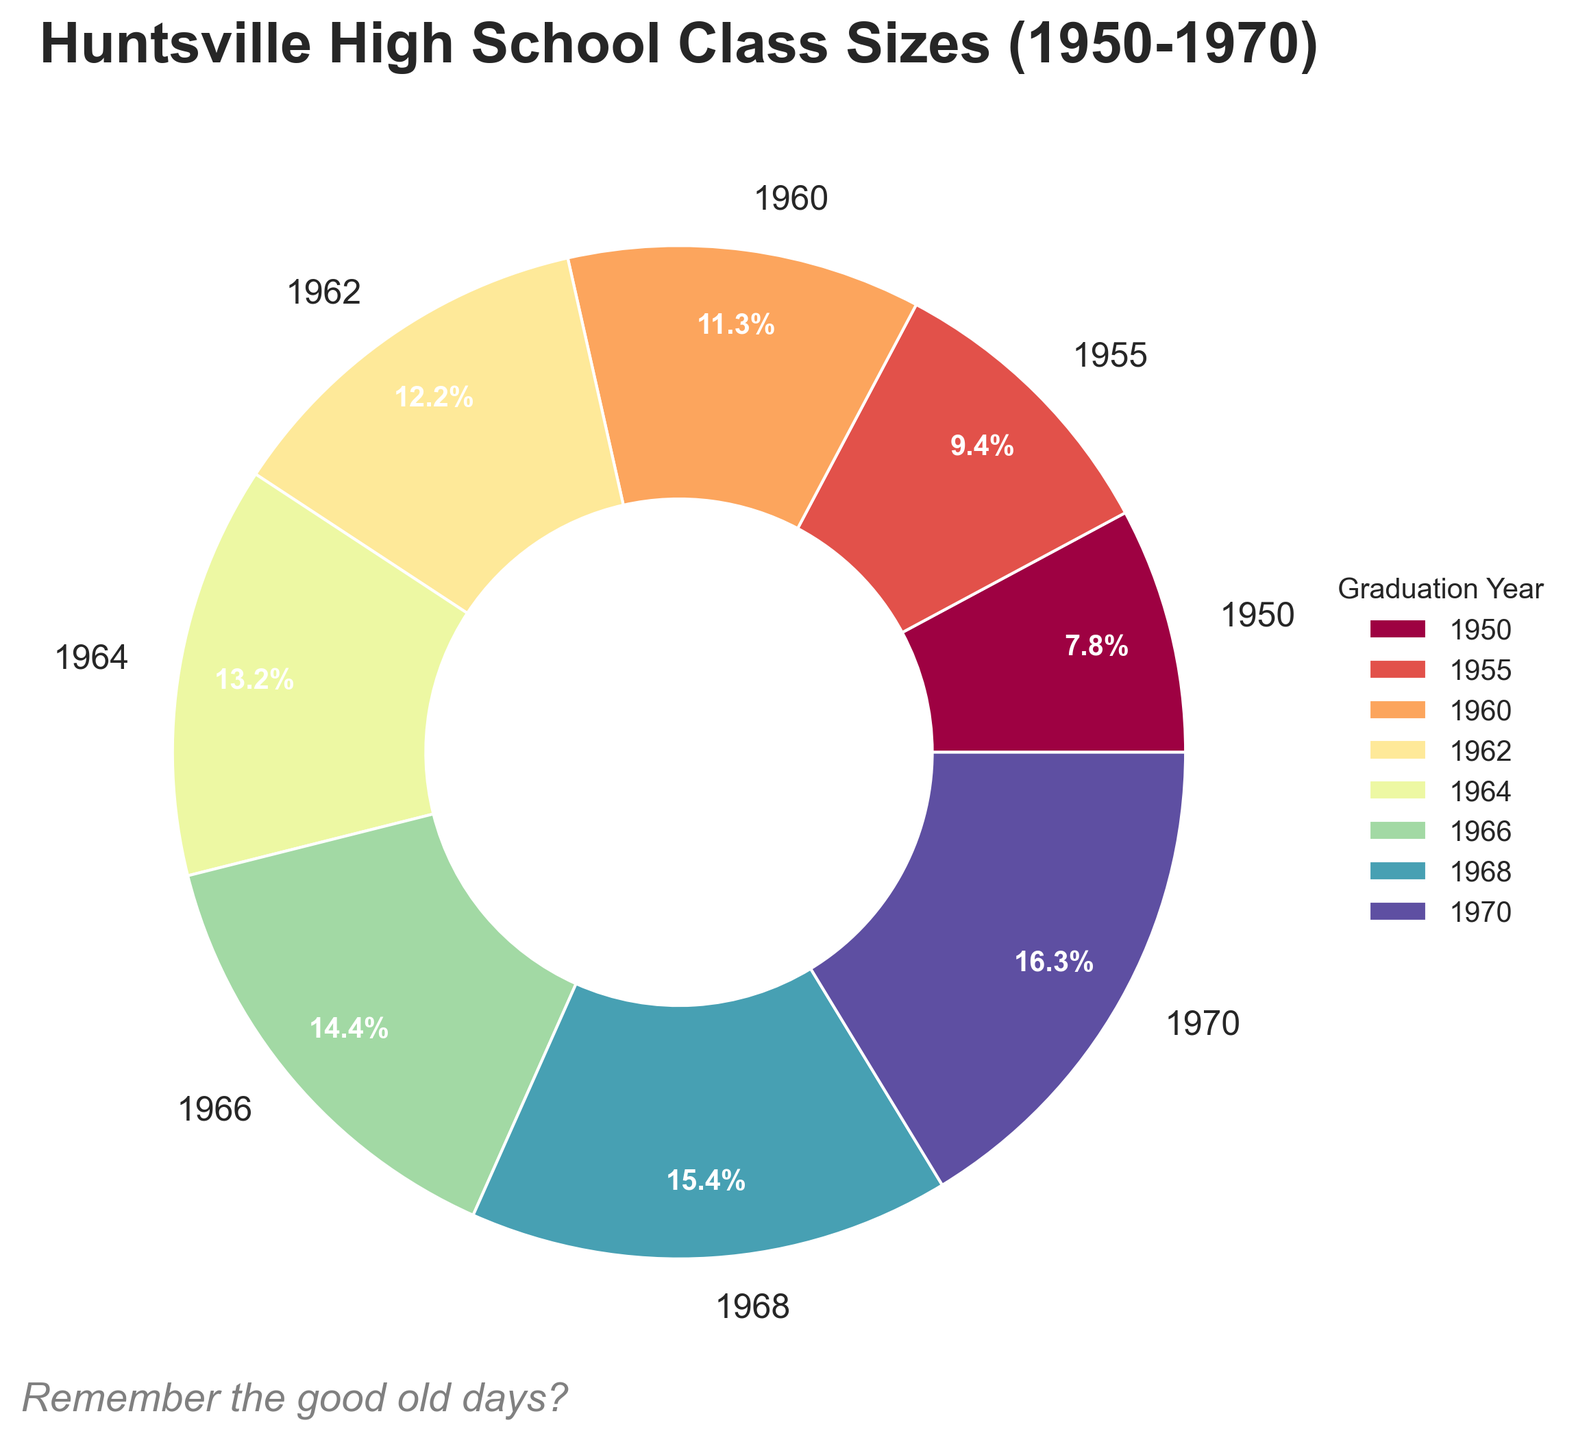What is the largest class size recorded from 1950 to 1970? By inspecting the figure, we can see that the largest portion of the pie chart is associated with the year 1970. Referring to the visual information in the figure for that year, the class size is the largest.
Answer: 260 What percentage of the total class sizes is represented by the year 1966? The pie chart auto-labels percentages, and for the year 1966, the portion of the pie chart representing that year is labeled with its percentage.
Answer: 13.3% How does the class size of 1955 compare to the class size of 1960? By observing the labeled percentages and corresponding wedge sizes, the class size for 1960 is larger. The pie chart segments indicate the class size of 1955 is smaller compared to 1960.
Answer: 1955’s class size is smaller Which two years have the closest class sizes? By examining the wedge sizes and percentages, the years 1968 and 1970 have very similar class sizes that make them the closest. They are visually close in size and their percentages are also near each other.
Answer: 1968 and 1970 How much did the class size increase from 1950 to 1970? The class size for 1950 is 125, and for 1970 it is 260. Subtracting the two values: 260 - 125 = 135.
Answer: 135 What is the average class size for the years 1950, 1960, and 1970? Summing the class sizes for these years (125 + 180 + 260) gives 565, and dividing by 3 gives an average: 565/3.
Answer: ~188.33 How many years had a class size greater than 200? By looking at the wedges representing different years, the years with class sizes greater than 200 are 1964, 1966, 1968, and 1970.
Answer: 4 years What is the combined class size for the years 1962 and 1964? Referring to the class sizes for these years from the figure: 195 (for 1962) + 210 (for 1964). Adding these values gives the total.
Answer: 405 Which year besides 1970 contributed the highest percentage to the total class sizes? Excluding 1970, visually inspecting the next largest segments and percentages associated, the year 1968 has the next highest percentage.
Answer: 1968 What is the smallest class size recorded in the 1960s? By observing the pie chart segments and corresponding figures, the year with the smallest class size in the 1960s is 1960 with a class size of 180.
Answer: 180 